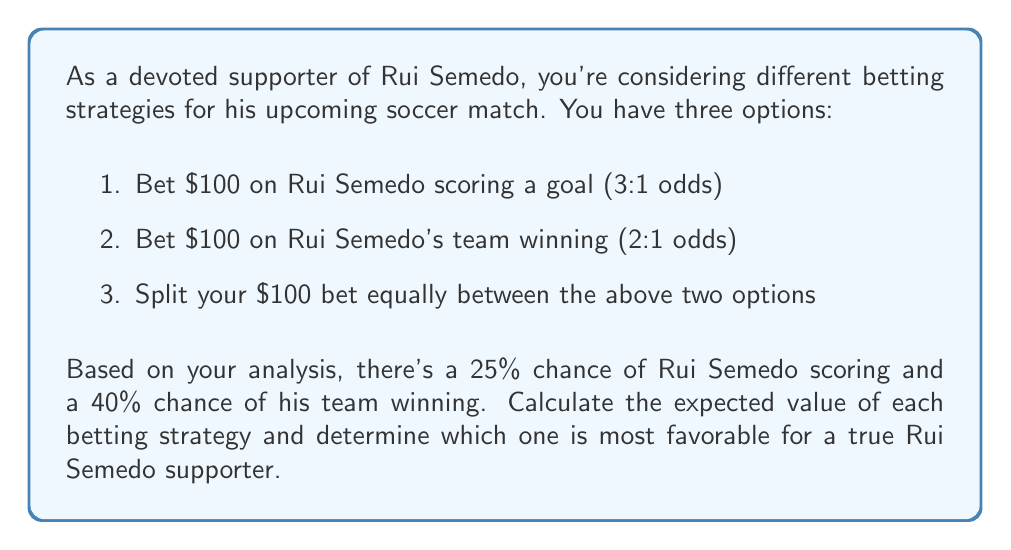Help me with this question. Let's calculate the expected value (EV) for each betting strategy:

1. Betting on Rui Semedo scoring:
   $$EV_1 = (0.25 \times 100 \times 3) + (0.75 \times -100) = 75 - 75 = 0$$

2. Betting on Rui Semedo's team winning:
   $$EV_2 = (0.40 \times 100 \times 2) + (0.60 \times -100) = 80 - 60 = 20$$

3. Splitting the bet:
   For this strategy, we need to calculate the EV for each half separately and sum them:
   
   Scoring bet: $$EV_{3a} = (0.25 \times 50 \times 3) + (0.75 \times -50) = 37.5 - 37.5 = 0$$
   Team winning bet: $$EV_{3b} = (0.40 \times 50 \times 2) + (0.60 \times -50) = 40 - 30 = 10$$
   
   Total EV for split bet: $$EV_3 = EV_{3a} + EV_{3b} = 0 + 10 = 10$$

Comparing the expected values:
$$EV_1 = 0$$
$$EV_2 = 20$$
$$EV_3 = 10$$

The most favorable betting strategy is option 2, betting on Rui Semedo's team winning, as it has the highest expected value of $20.
Answer: The most favorable betting strategy is to bet $100 on Rui Semedo's team winning, with an expected value of $20. 